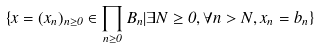Convert formula to latex. <formula><loc_0><loc_0><loc_500><loc_500>\{ x = ( x _ { n } ) _ { n \geq 0 } \in \prod _ { n \geq 0 } B _ { n } | \exists N \geq 0 , \forall n > N , x _ { n } = b _ { n } \}</formula> 